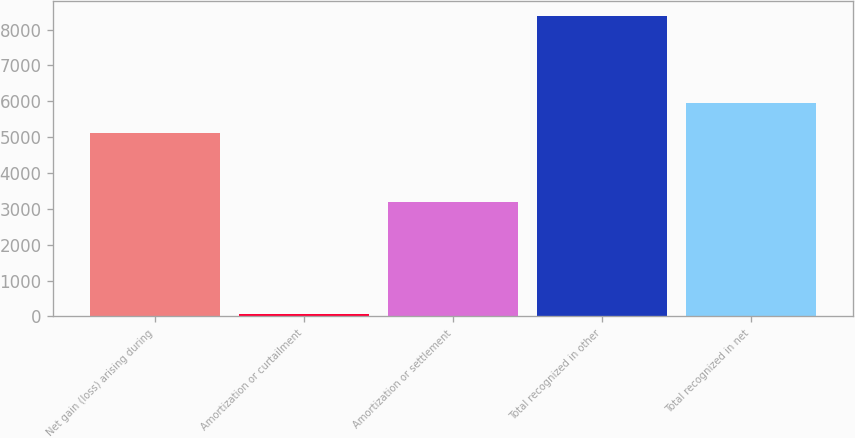<chart> <loc_0><loc_0><loc_500><loc_500><bar_chart><fcel>Net gain (loss) arising during<fcel>Amortization or curtailment<fcel>Amortization or settlement<fcel>Total recognized in other<fcel>Total recognized in net<nl><fcel>5128<fcel>62<fcel>3180<fcel>8370<fcel>5958.8<nl></chart> 